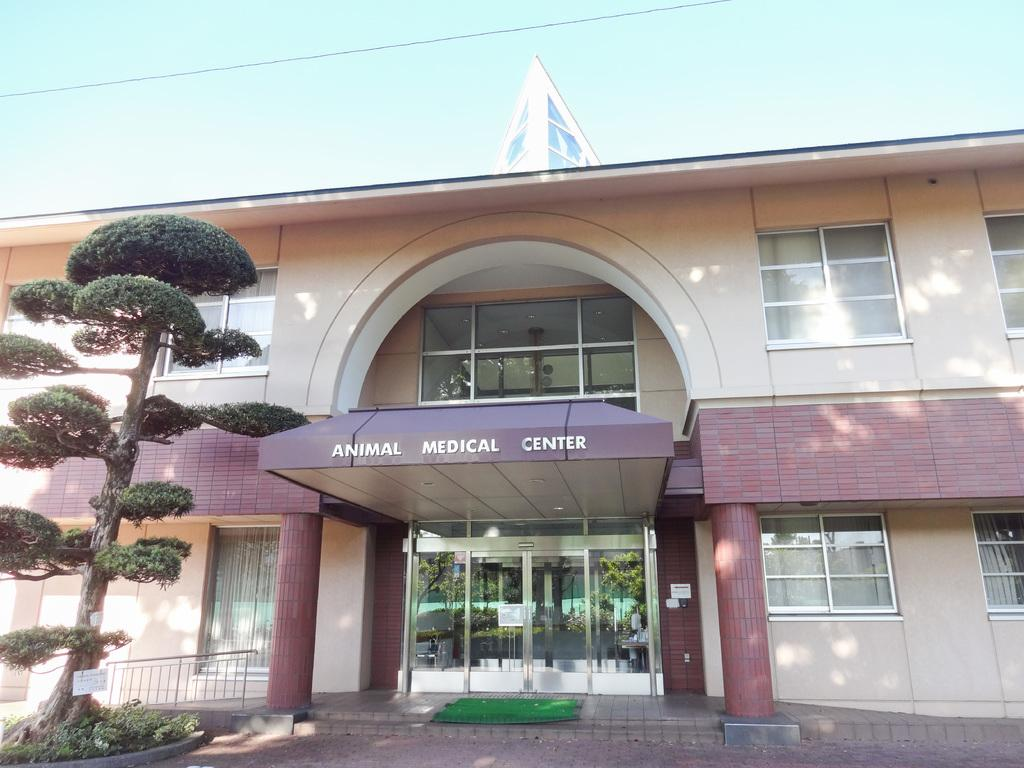<image>
Create a compact narrative representing the image presented. The Animal Medical Center is a big brown building. 